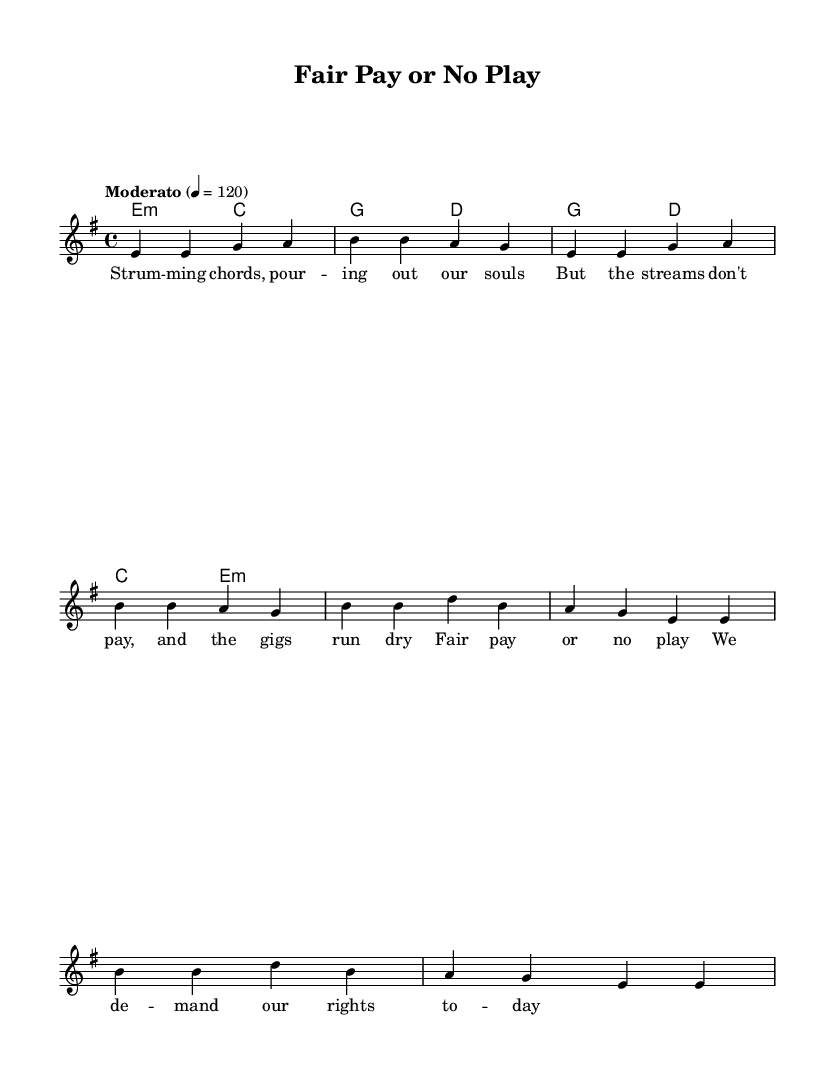What is the key signature of this music? The key signature is E minor, indicated by one sharp (F#).
Answer: E minor What is the time signature of this music? The time signature is 4/4, which means there are four beats in each measure.
Answer: 4/4 What is the tempo marking of this music? The tempo marking is Moderato, indicated as 4 = 120, suggesting a moderate pace.
Answer: Moderato How many measures are in the verse section? The verse section consists of four measures as indicated by the musical notation.
Answer: 4 How many chords are used in the chorus section? The chorus section uses two different chords, G and D, as shown in the chord progression.
Answer: 2 What is the lyrical theme of the song? The lyrical theme reflects a demand for fair compensation for musicians' rights, as highlighted in the lyrics.
Answer: Fair pay for musicians Which musical genre does this piece belong to? This piece belongs to the Rock genre, especially characterized by its protest theme and advocacy for musicians' rights.
Answer: Rock 